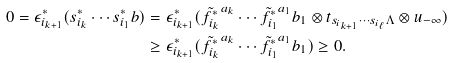<formula> <loc_0><loc_0><loc_500><loc_500>0 = \epsilon ^ { * } _ { i _ { k + 1 } } ( s ^ { * } _ { i _ { k } } \cdots s ^ { * } _ { i _ { 1 } } b ) & = \epsilon ^ { * } _ { i _ { k + 1 } } ( \tilde { f _ { i _ { k } } ^ { * } } ^ { a _ { k } } \cdots \tilde { f _ { i _ { 1 } } ^ { * } } ^ { a _ { 1 } } b _ { 1 } \otimes t _ { s _ { i _ { k + 1 } } \cdots s _ { i _ { \ell } } \Lambda } \otimes u _ { - \infty } ) \\ & \geq \epsilon ^ { * } _ { i _ { k + 1 } } ( \tilde { f _ { i _ { k } } ^ { * } } ^ { a _ { k } } \cdots \tilde { f _ { i _ { 1 } } ^ { * } } ^ { a _ { 1 } } b _ { 1 } ) \geq 0 .</formula> 